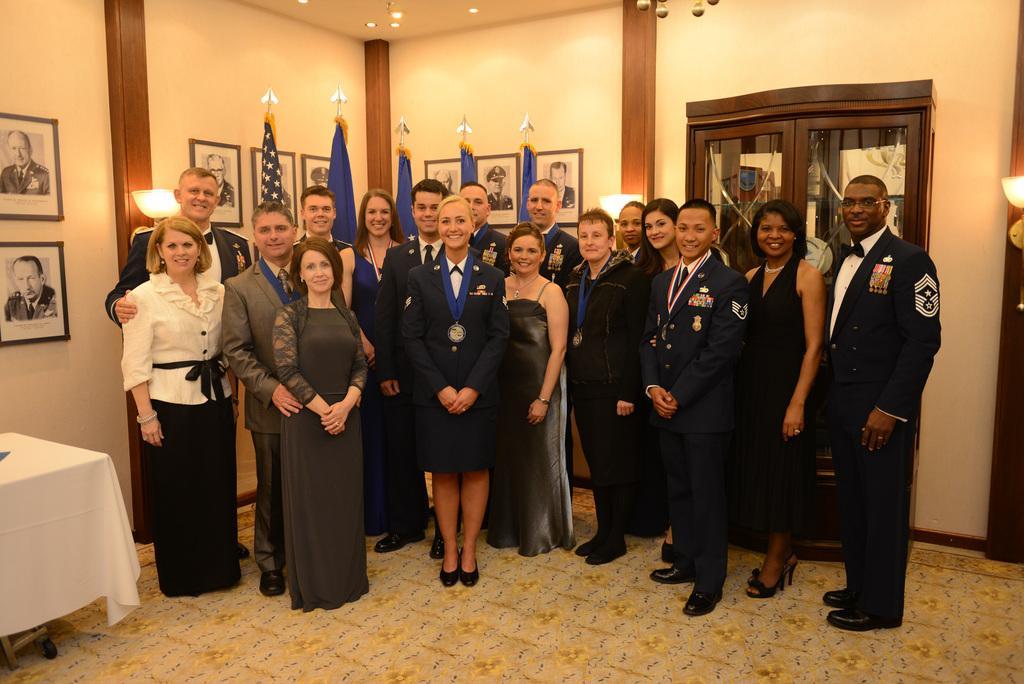Describe this image in one or two sentences. There are some people standing in this picture. There are men and women in this group. All of them were smiling. In the background, there are some flags and some photographs attached to the wall. In the left side there is a table. 